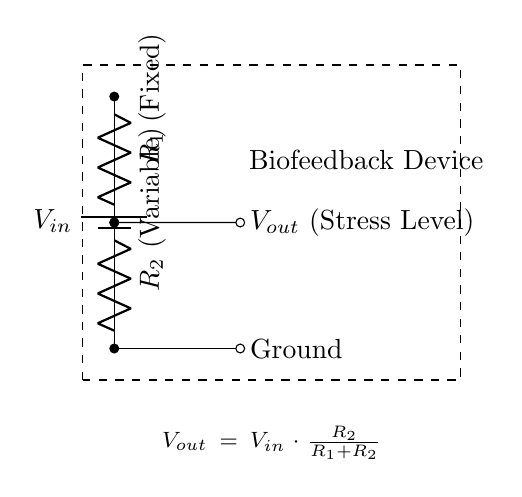What components are in the circuit? The circuit consists of a battery, two resistors, and a connection to ground.
Answer: Battery, Resistors What does \( V_{out} \) represent in this circuit? \( V_{out} \) represents the output voltage, which correlates to the stress level measured by the biofeedback device, derived from the voltage divider formula.
Answer: Stress Level What is the relationship between \( V_{in} \), \( R_1 \), and \( R_2 \) in determining \( V_{out} \)? The output voltage \( V_{out} \) is calculated using the formula \( V_{out} = V_{in} \cdot \frac{R_2}{R_1 + R_2} \), indicating that \( V_{out} \) depends on the ratio of the resistors and the input voltage.
Answer: Voltage Divider Equation If \( R_1 \) is three times larger than \( R_2 \), what can be inferred about \( V_{out} \)? If \( R_1 \) is three times \( R_2 \), \( V_{out} \) will be one-fourth of \( V_{in} \) based on the divider equation, indicating how the resistance ratio affects the output.
Answer: One-fourth of \( V_{in} \) How would increasing \( R_2 \) affect \( V_{out} \)? Increasing \( R_2 \) would raise \( V_{out} \) because it increases the fraction \( \frac{R_2}{R_1 + R_2} \), resulting in a higher proportion of \( V_{in} \) being output.
Answer: Increase \( V_{out} \) What happens to \( V_{out} \) if both resistors are equal? When \( R_1 \) equals \( R_2 \), \( V_{out} \) becomes half of \( V_{in} \) as the voltage divider divides the input voltage equally between the two resistors.
Answer: Half of \( V_{in} \) 